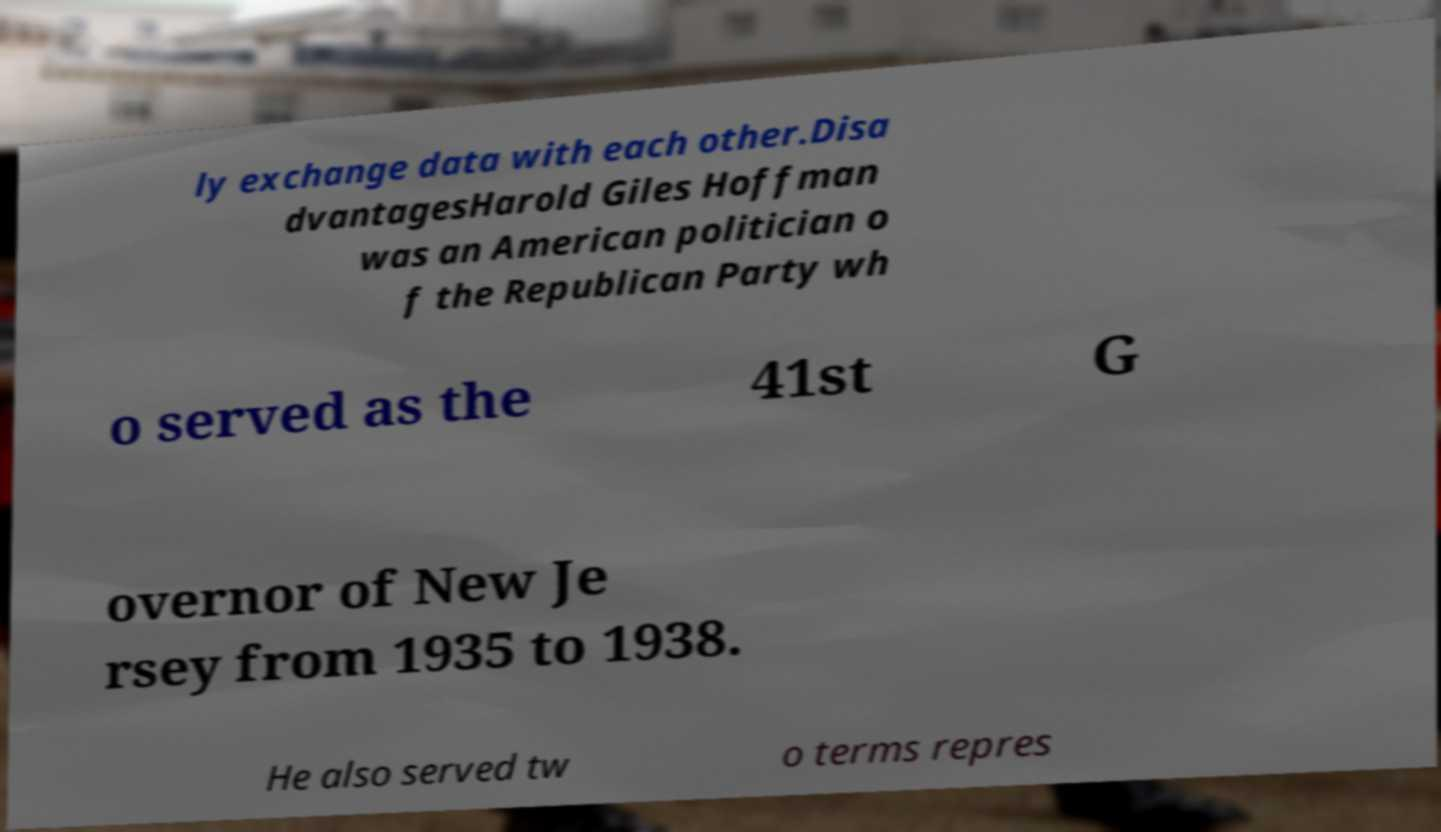Could you extract and type out the text from this image? ly exchange data with each other.Disa dvantagesHarold Giles Hoffman was an American politician o f the Republican Party wh o served as the 41st G overnor of New Je rsey from 1935 to 1938. He also served tw o terms repres 